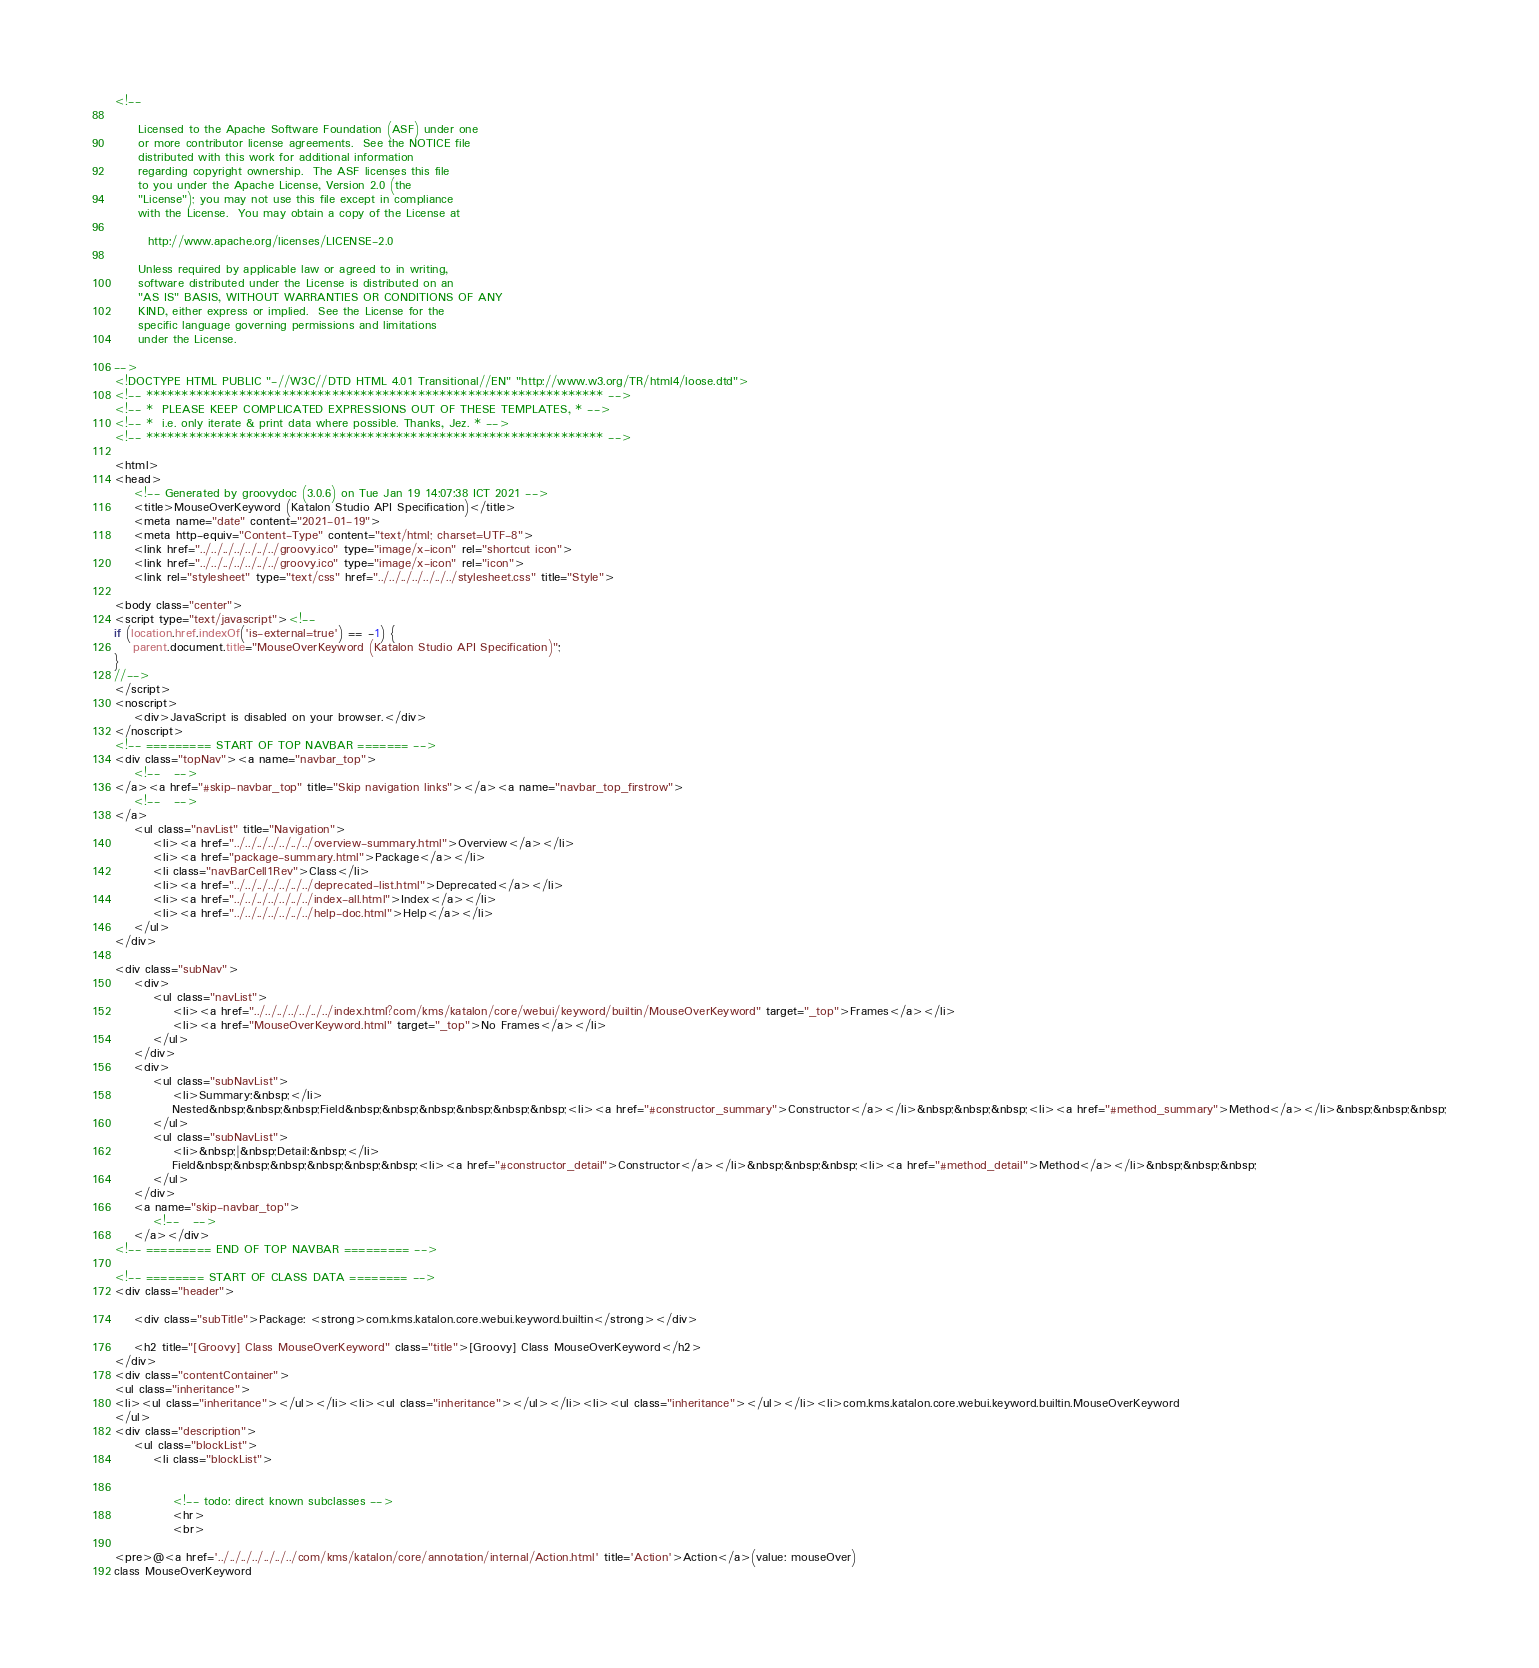Convert code to text. <code><loc_0><loc_0><loc_500><loc_500><_HTML_><!--

     Licensed to the Apache Software Foundation (ASF) under one
     or more contributor license agreements.  See the NOTICE file
     distributed with this work for additional information
     regarding copyright ownership.  The ASF licenses this file
     to you under the Apache License, Version 2.0 (the
     "License"); you may not use this file except in compliance
     with the License.  You may obtain a copy of the License at

       http://www.apache.org/licenses/LICENSE-2.0

     Unless required by applicable law or agreed to in writing,
     software distributed under the License is distributed on an
     "AS IS" BASIS, WITHOUT WARRANTIES OR CONDITIONS OF ANY
     KIND, either express or implied.  See the License for the
     specific language governing permissions and limitations
     under the License.

-->
<!DOCTYPE HTML PUBLIC "-//W3C//DTD HTML 4.01 Transitional//EN" "http://www.w3.org/TR/html4/loose.dtd">
<!-- **************************************************************** -->
<!-- *  PLEASE KEEP COMPLICATED EXPRESSIONS OUT OF THESE TEMPLATES, * -->
<!-- *  i.e. only iterate & print data where possible. Thanks, Jez. * -->
<!-- **************************************************************** -->

<html>
<head>
    <!-- Generated by groovydoc (3.0.6) on Tue Jan 19 14:07:38 ICT 2021 -->
    <title>MouseOverKeyword (Katalon Studio API Specification)</title>
    <meta name="date" content="2021-01-19">
    <meta http-equiv="Content-Type" content="text/html; charset=UTF-8">
    <link href="../../../../../../../groovy.ico" type="image/x-icon" rel="shortcut icon">
    <link href="../../../../../../../groovy.ico" type="image/x-icon" rel="icon">
    <link rel="stylesheet" type="text/css" href="../../../../../../../stylesheet.css" title="Style">

<body class="center">
<script type="text/javascript"><!--
if (location.href.indexOf('is-external=true') == -1) {
    parent.document.title="MouseOverKeyword (Katalon Studio API Specification)";
}
//-->
</script>
<noscript>
    <div>JavaScript is disabled on your browser.</div>
</noscript>
<!-- ========= START OF TOP NAVBAR ======= -->
<div class="topNav"><a name="navbar_top">
    <!--   -->
</a><a href="#skip-navbar_top" title="Skip navigation links"></a><a name="navbar_top_firstrow">
    <!--   -->
</a>
    <ul class="navList" title="Navigation">
        <li><a href="../../../../../../../overview-summary.html">Overview</a></li>
        <li><a href="package-summary.html">Package</a></li>
        <li class="navBarCell1Rev">Class</li>
        <li><a href="../../../../../../../deprecated-list.html">Deprecated</a></li>
        <li><a href="../../../../../../../index-all.html">Index</a></li>
        <li><a href="../../../../../../../help-doc.html">Help</a></li>
    </ul>
</div>

<div class="subNav">
    <div>
        <ul class="navList">
            <li><a href="../../../../../../../index.html?com/kms/katalon/core/webui/keyword/builtin/MouseOverKeyword" target="_top">Frames</a></li>
            <li><a href="MouseOverKeyword.html" target="_top">No Frames</a></li>
        </ul>
    </div>
    <div>
        <ul class="subNavList">
            <li>Summary:&nbsp;</li>
            Nested&nbsp;&nbsp;&nbsp;Field&nbsp;&nbsp;&nbsp;&nbsp;&nbsp;&nbsp;<li><a href="#constructor_summary">Constructor</a></li>&nbsp;&nbsp;&nbsp;<li><a href="#method_summary">Method</a></li>&nbsp;&nbsp;&nbsp;
        </ul>
        <ul class="subNavList">
            <li>&nbsp;|&nbsp;Detail:&nbsp;</li>
            Field&nbsp;&nbsp;&nbsp;&nbsp;&nbsp;&nbsp;<li><a href="#constructor_detail">Constructor</a></li>&nbsp;&nbsp;&nbsp;<li><a href="#method_detail">Method</a></li>&nbsp;&nbsp;&nbsp;
        </ul>
    </div>
    <a name="skip-navbar_top">
        <!--   -->
    </a></div>
<!-- ========= END OF TOP NAVBAR ========= -->

<!-- ======== START OF CLASS DATA ======== -->
<div class="header">

    <div class="subTitle">Package: <strong>com.kms.katalon.core.webui.keyword.builtin</strong></div>

    <h2 title="[Groovy] Class MouseOverKeyword" class="title">[Groovy] Class MouseOverKeyword</h2>
</div>
<div class="contentContainer">
<ul class="inheritance">
<li><ul class="inheritance"></ul></li><li><ul class="inheritance"></ul></li><li><ul class="inheritance"></ul></li><li>com.kms.katalon.core.webui.keyword.builtin.MouseOverKeyword
</ul>
<div class="description">
    <ul class="blockList">
        <li class="blockList">


            <!-- todo: direct known subclasses -->
            <hr>
            <br>

<pre>@<a href='../../../../../../../com/kms/katalon/core/annotation/internal/Action.html' title='Action'>Action</a>(value: mouseOver)
class MouseOverKeyword</code> 